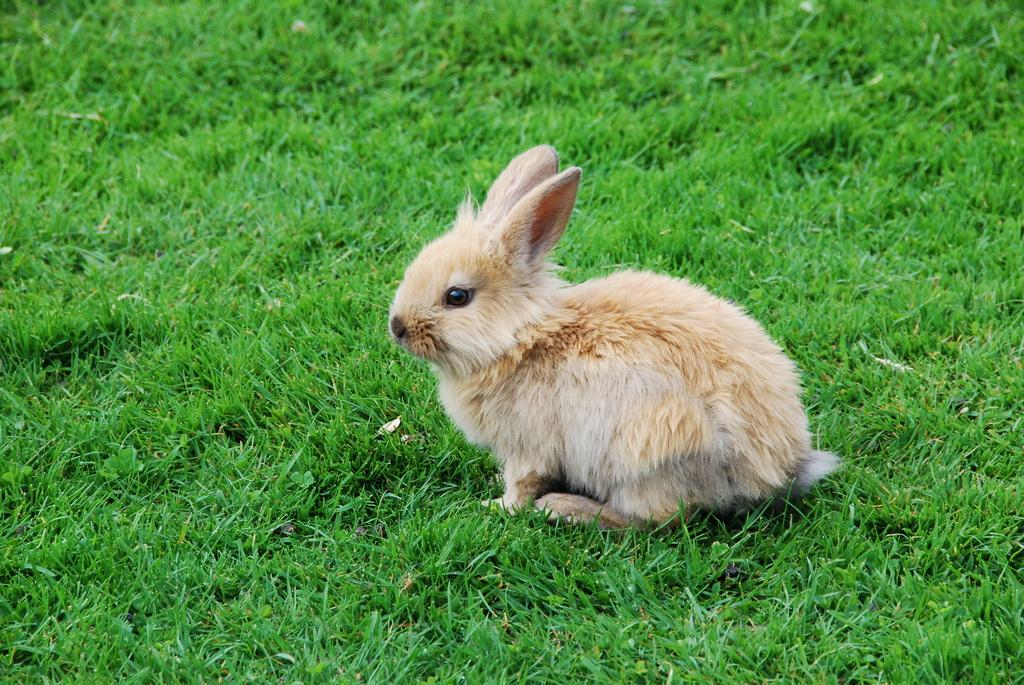What type of vegetation can be seen in the image? There is green grass in the image. What animal is present in the image? There is a rabbit in the image. What is the rabbit thinking about in the image? There is no way to determine what the rabbit is thinking about in the image, as thoughts are not visible. How many necks does the rabbit have in the image? The rabbit has one neck in the image. 